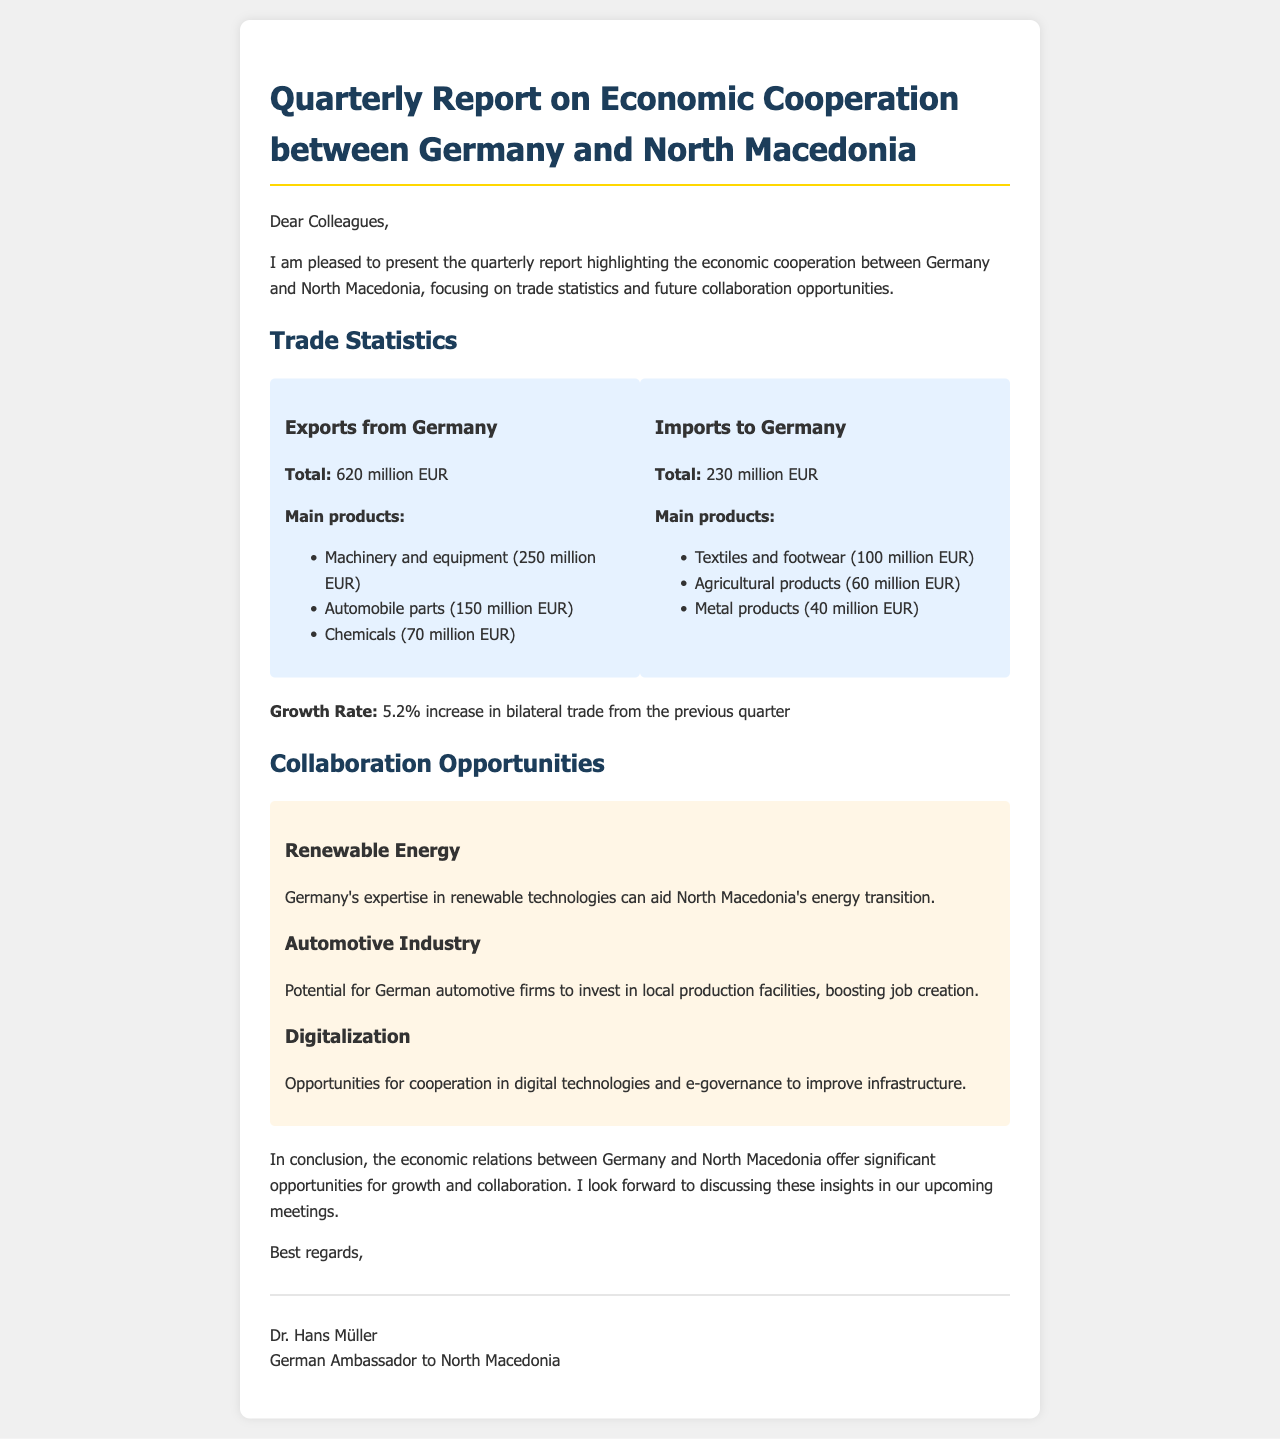What is the total value of exports from Germany? The total value of exports from Germany is provided in the document under trade statistics.
Answer: 620 million EUR What are the main products exported from Germany? The document lists three main products exported from Germany under the exports section.
Answer: Machinery and equipment, automobile parts, chemicals What is the total value of imports to Germany from North Macedonia? The total value of imports to Germany is found in the imports section of the trade statistics.
Answer: 230 million EUR What is the growth rate of bilateral trade from the previous quarter? The growth rate of bilateral trade is explicitly mentioned in the document.
Answer: 5.2% Which sector offers collaboration opportunities related to renewable energy? The document specifically names renewable energy as a sector for collaboration opportunities.
Answer: Renewable Energy What potential investment opportunity is mentioned in the automotive industry? The document discusses potential investments in local production facilities within the automotive sector.
Answer: Local production facilities What cooperation opportunity is mentioned for digitalization? The document highlights specific opportunities for cooperation in digital technologies and e-governance.
Answer: Digital technologies and e-governance Who is the author of the email? The document concludes with the signature of the email's author provided at the end.
Answer: Dr. Hans Müller What is the subject of the email? The subject of the email is the focus of the entire document, as stated in the heading.
Answer: Quarterly Report on Economic Cooperation between Germany and North Macedonia 